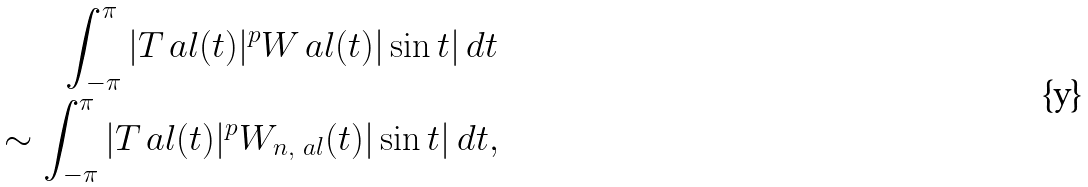Convert formula to latex. <formula><loc_0><loc_0><loc_500><loc_500>\int _ { - \pi } ^ { \pi } | T _ { \ } a l ( t ) | ^ { p } W _ { \ } a l ( t ) | \sin t | \, d t \\ \sim \int _ { - \pi } ^ { \pi } | T _ { \ } a l ( t ) | ^ { p } W _ { n , \ a l } ( t ) | \sin t | \, d t ,</formula> 